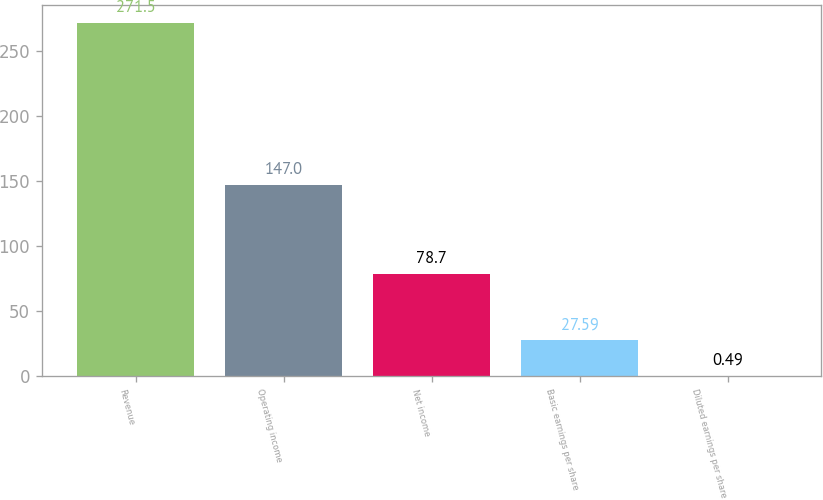Convert chart to OTSL. <chart><loc_0><loc_0><loc_500><loc_500><bar_chart><fcel>Revenue<fcel>Operating income<fcel>Net income<fcel>Basic earnings per share<fcel>Diluted earnings per share<nl><fcel>271.5<fcel>147<fcel>78.7<fcel>27.59<fcel>0.49<nl></chart> 